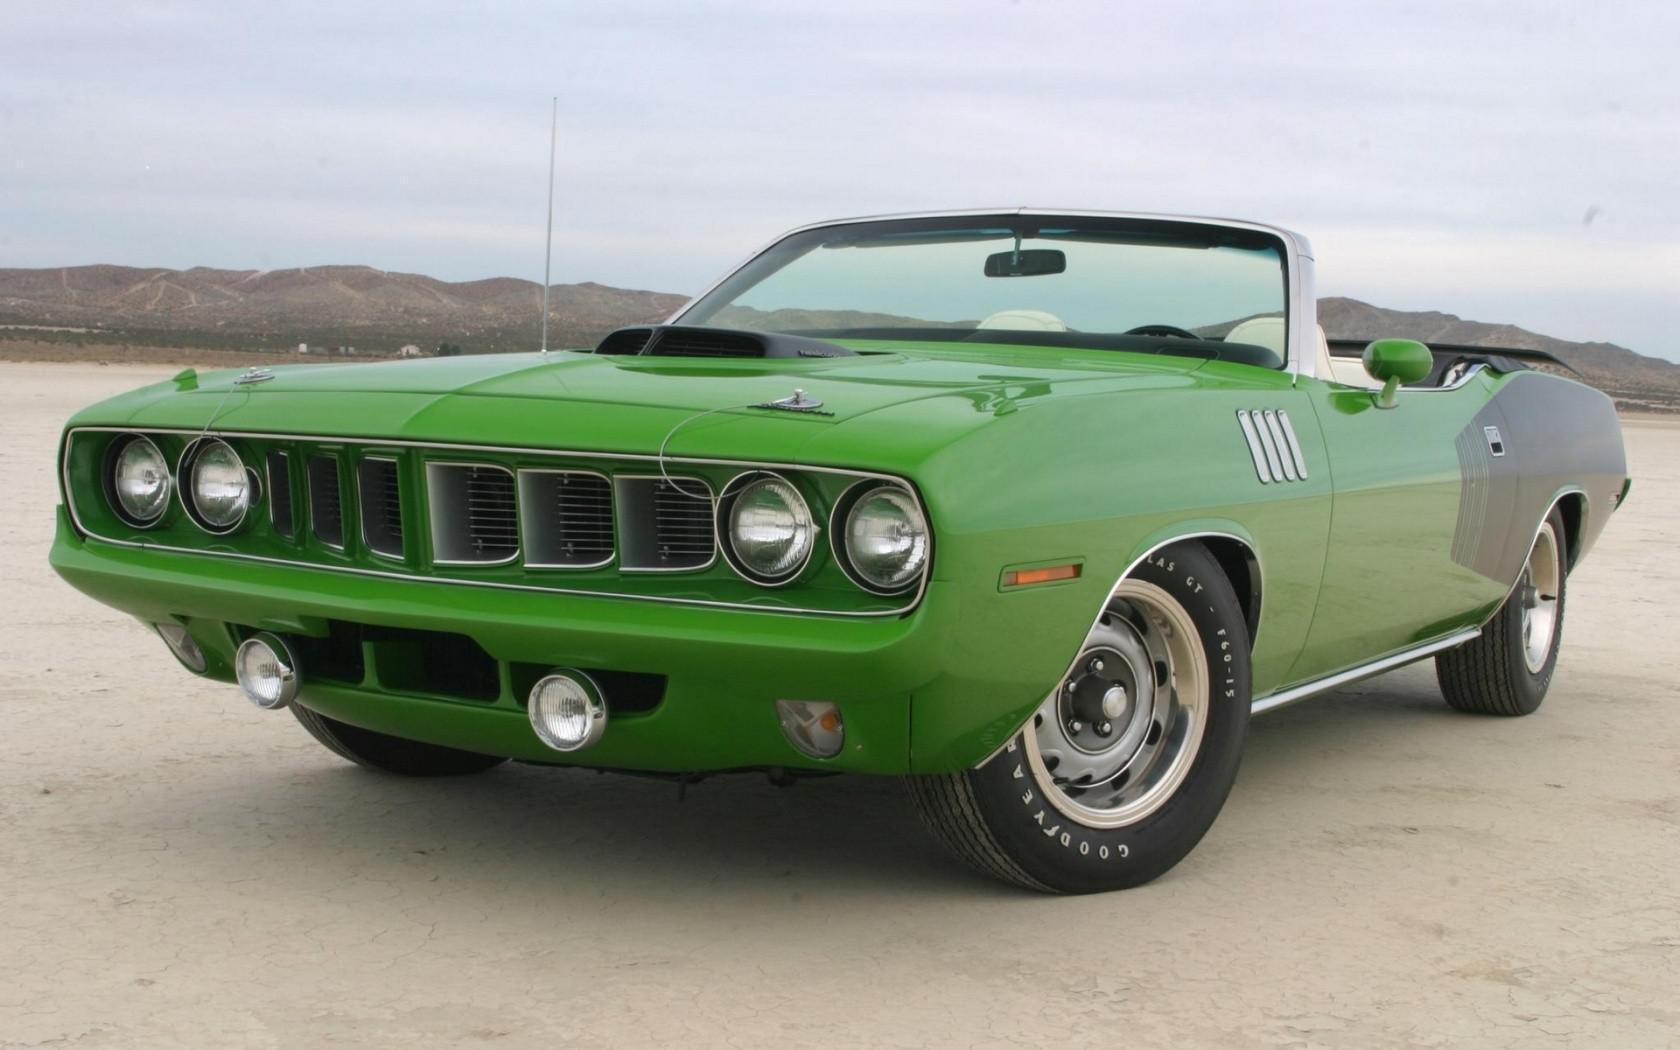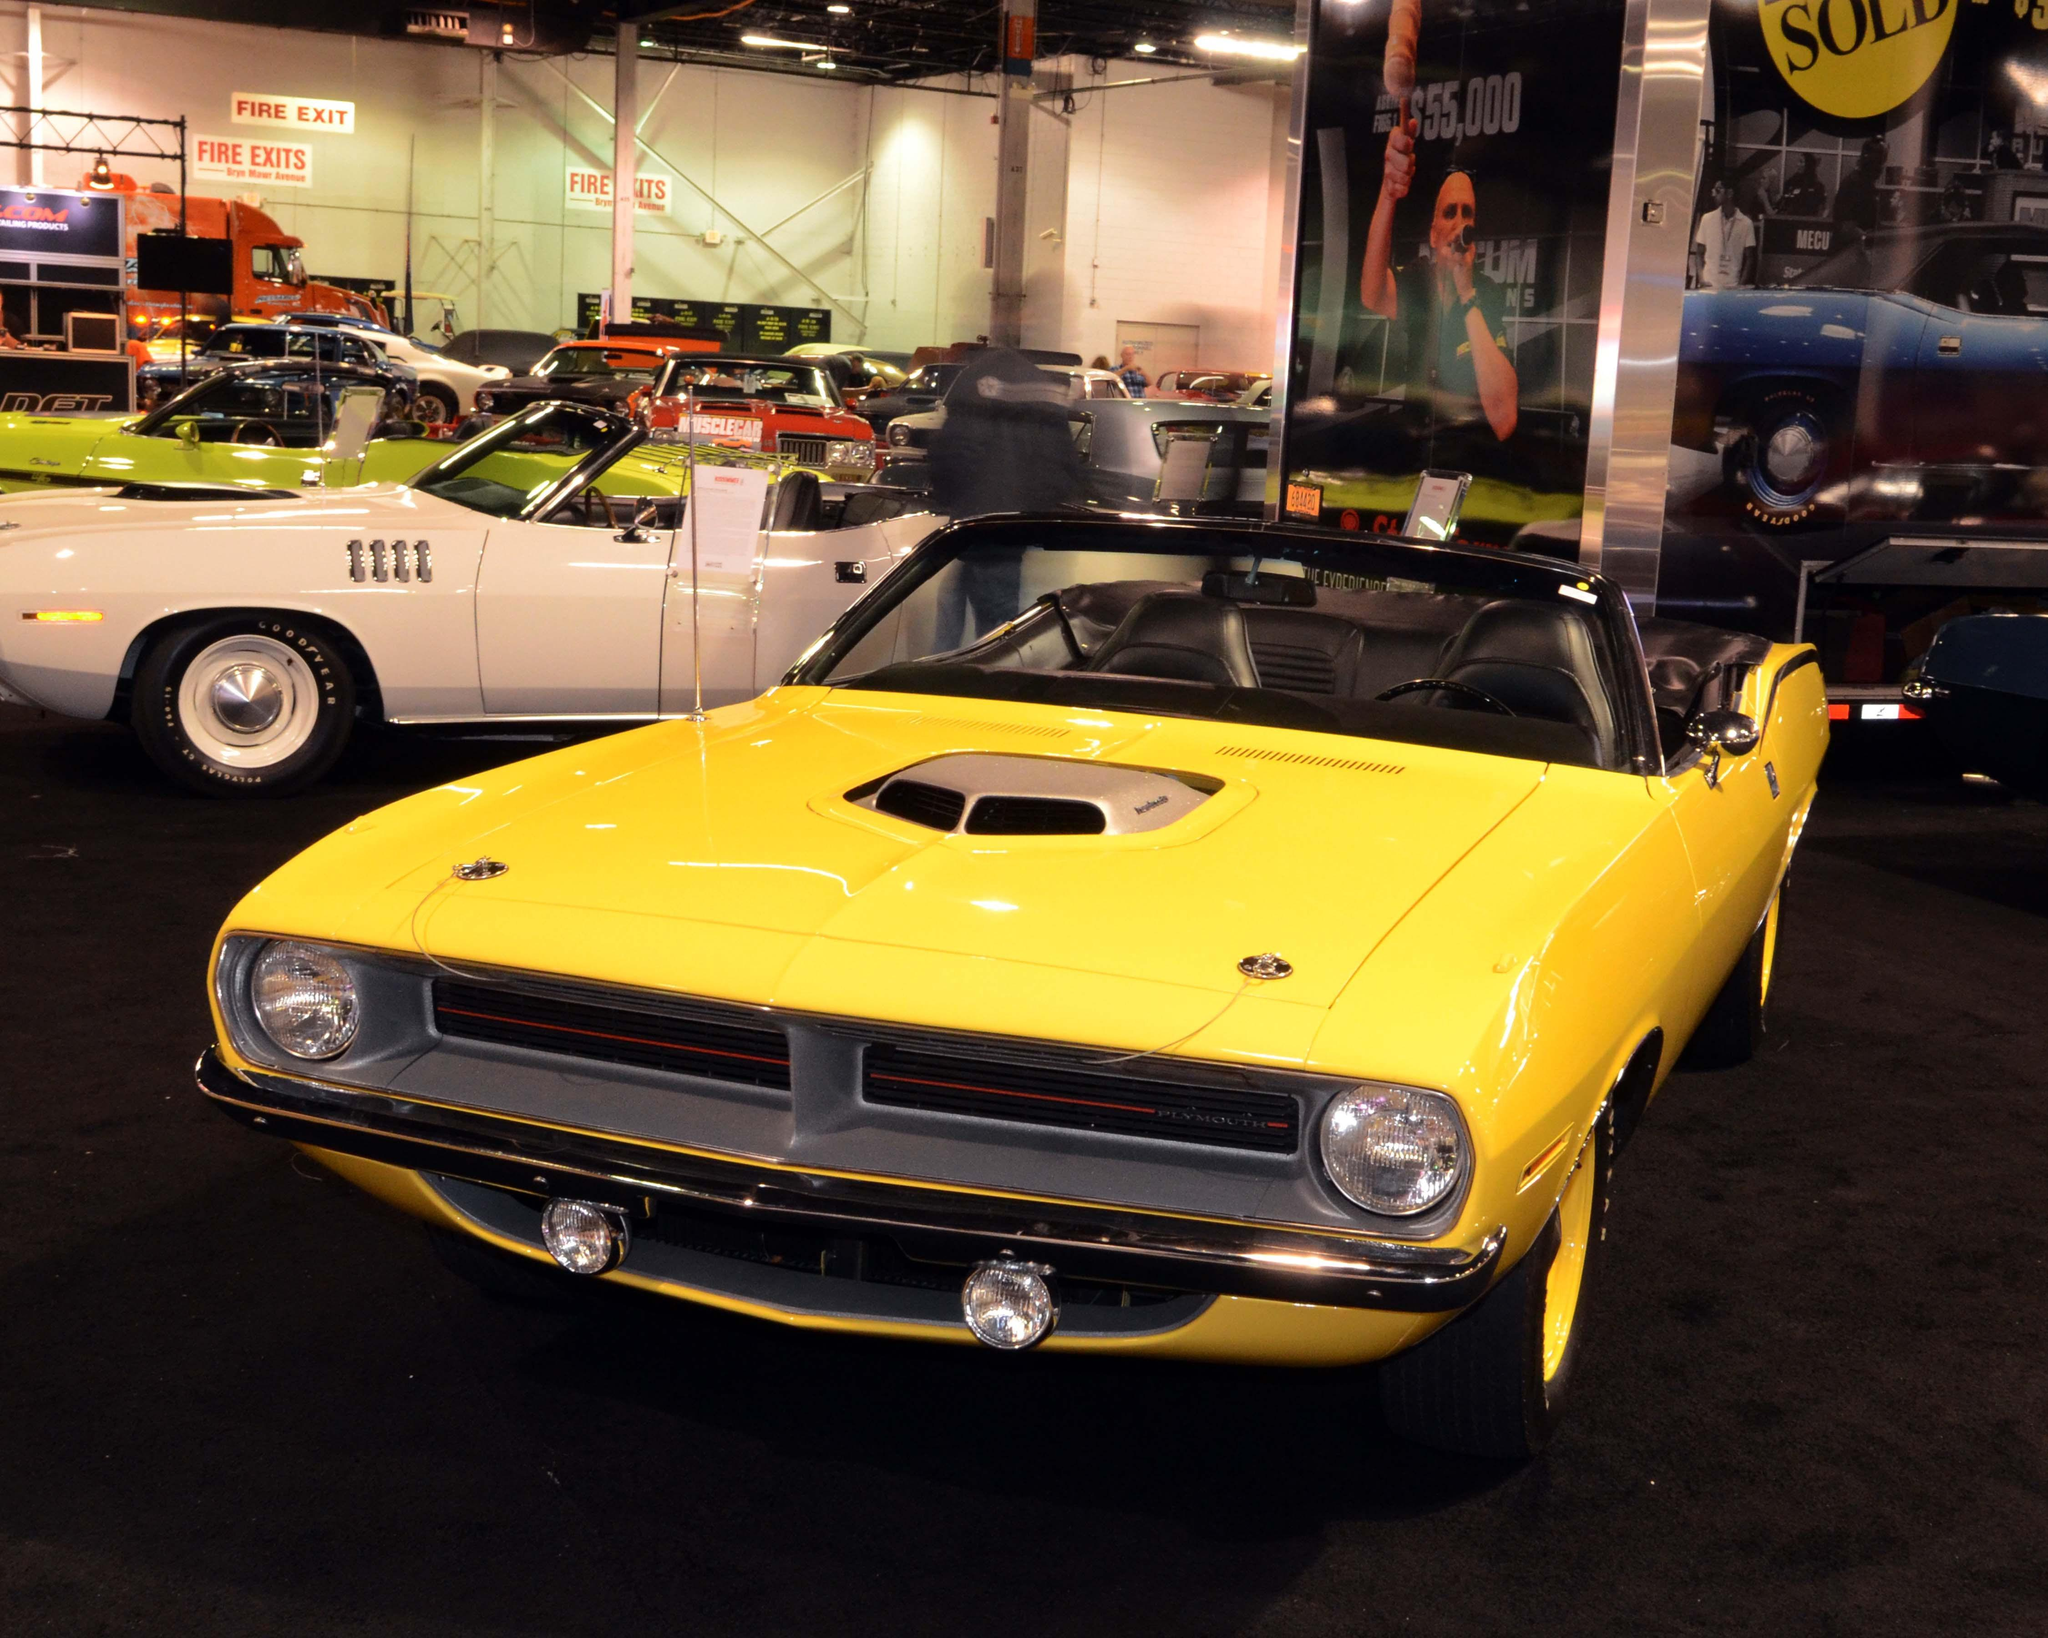The first image is the image on the left, the second image is the image on the right. Examine the images to the left and right. Is the description "At least one image features a yellow car in the foreground." accurate? Answer yes or no. Yes. 